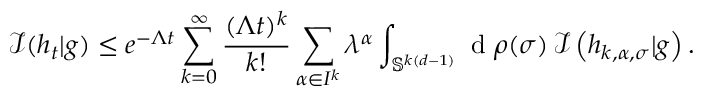<formula> <loc_0><loc_0><loc_500><loc_500>\mathcal { I } ( h _ { t } | g ) \leq e ^ { - \Lambda t } \sum _ { k = 0 } ^ { \infty } \frac { ( \Lambda t ) ^ { k } } { k ! } \sum _ { \alpha \in I ^ { k } } \lambda ^ { \alpha } \int _ { \mathbb { S } ^ { k ( d - 1 ) } } d \rho ( \sigma ) \, \mathcal { I } \left ( h _ { k , \alpha , \sigma } | g \right ) .</formula> 